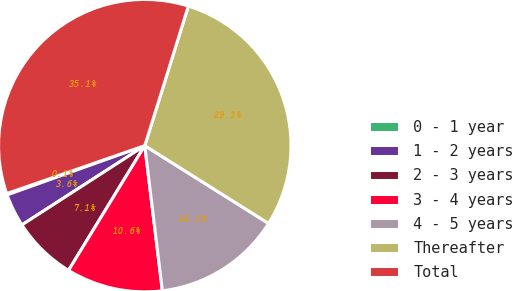Convert chart to OTSL. <chart><loc_0><loc_0><loc_500><loc_500><pie_chart><fcel>0 - 1 year<fcel>1 - 2 years<fcel>2 - 3 years<fcel>3 - 4 years<fcel>4 - 5 years<fcel>Thereafter<fcel>Total<nl><fcel>0.15%<fcel>3.65%<fcel>7.15%<fcel>10.65%<fcel>14.15%<fcel>29.12%<fcel>35.14%<nl></chart> 